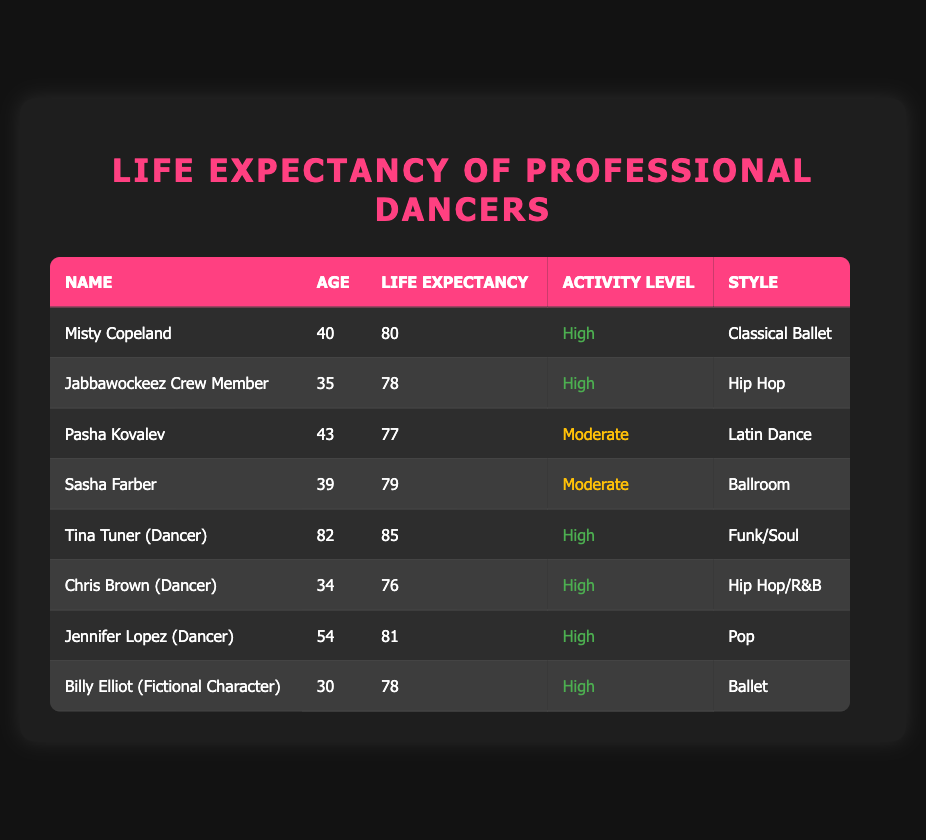What is the life expectancy of Misty Copeland? From the table, under the "Life Expectancy" column for Misty Copeland, the value is 80. Therefore, the life expectancy for Misty Copeland is clearly stated in the row corresponding to her name.
Answer: 80 What dancing style does the Jabbawockeez Crew Member perform? The table lists the Jabbawockeez Crew Member in the "Style" column, which shows "Hip Hop." This indicates the dancing style they perform.
Answer: Hip Hop Is Jennifer Lopez's life expectancy higher than that of Chris Brown? Comparing the "Life Expectancy" values, Jennifer Lopez's life expectancy is 81, while Chris Brown's is 76. Since 81 is greater than 76, we conclude that her life expectancy is higher.
Answer: Yes How many dancers have a life expectancy of 78? The table shows two dancers with a life expectancy of 78: Jabbawockeez Crew Member and Billy Elliot. By counting these entries, we find there are exactly two.
Answer: 2 What is the average life expectancy of dancers with a high activity level? The dancers with a high activity level are Misty Copeland (80), Jabbawockeez Crew Member (78), Tina Tuner (85), Chris Brown (76), Jennifer Lopez (81), and Billy Elliot (78). First, we sum their life expectancies: 80 + 78 + 85 + 76 + 81 + 78 = 478. Since there are 6 dancers, we calculate the average: 478 / 6 ≈ 79.67.
Answer: 79.67 Are all dancers with a high activity level younger than those with a moderate activity level? Evaluating the ages, Misty Copeland (40), Jabbawockeez Crew Member (35), Tina Tuner (82), Chris Brown (34), and Jennifer Lopez (54) are all high activity dancers, while Pasha Kovalev (43) and Sasha Farber (39) are moderate. Since Tina Tuner is older than the moderate dancers, not all high activity dancers are younger.
Answer: No Who is the oldest dancer in the table? The age column lists Tina Tuner as 82 years old, which is higher than any other dancers' ages recorded in the table. Thus, she is confirmed as the oldest dancer in the data.
Answer: Tina Tuner What is the difference in life expectancy between the youngest and oldest dancers? The youngest dancer is Chris Brown (34) with a life expectancy of 76, while the oldest is Tina Tuner (82) with a life expectancy of 85. To find the difference, calculate 85 - 76, which equals 9.
Answer: 9 Which dance styles have the highest life expectancy values? Analyzing the table, the highest life expectancy values are 85 for Tina Tuner (Funk/Soul), 81 for Jennifer Lopez (Pop), and 80 for Misty Copeland (Classical Ballet). The styles associated with these high values thus are Funk/Soul, Pop, and Classical Ballet.
Answer: Funk/Soul, Pop, Classical Ballet 